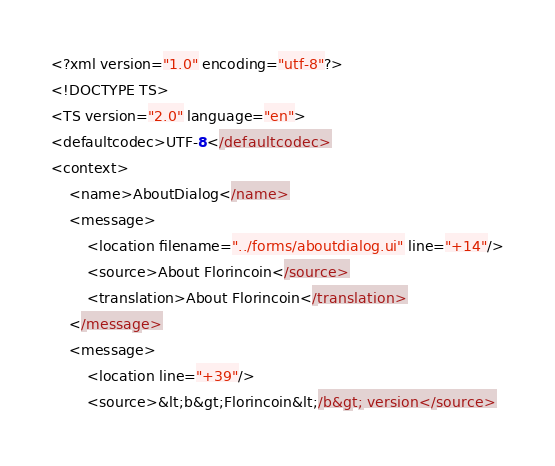Convert code to text. <code><loc_0><loc_0><loc_500><loc_500><_TypeScript_><?xml version="1.0" encoding="utf-8"?>
<!DOCTYPE TS>
<TS version="2.0" language="en">
<defaultcodec>UTF-8</defaultcodec>
<context>
    <name>AboutDialog</name>
    <message>
        <location filename="../forms/aboutdialog.ui" line="+14"/>
        <source>About Florincoin</source>
        <translation>About Florincoin</translation>
    </message>
    <message>
        <location line="+39"/>
        <source>&lt;b&gt;Florincoin&lt;/b&gt; version</source></code> 